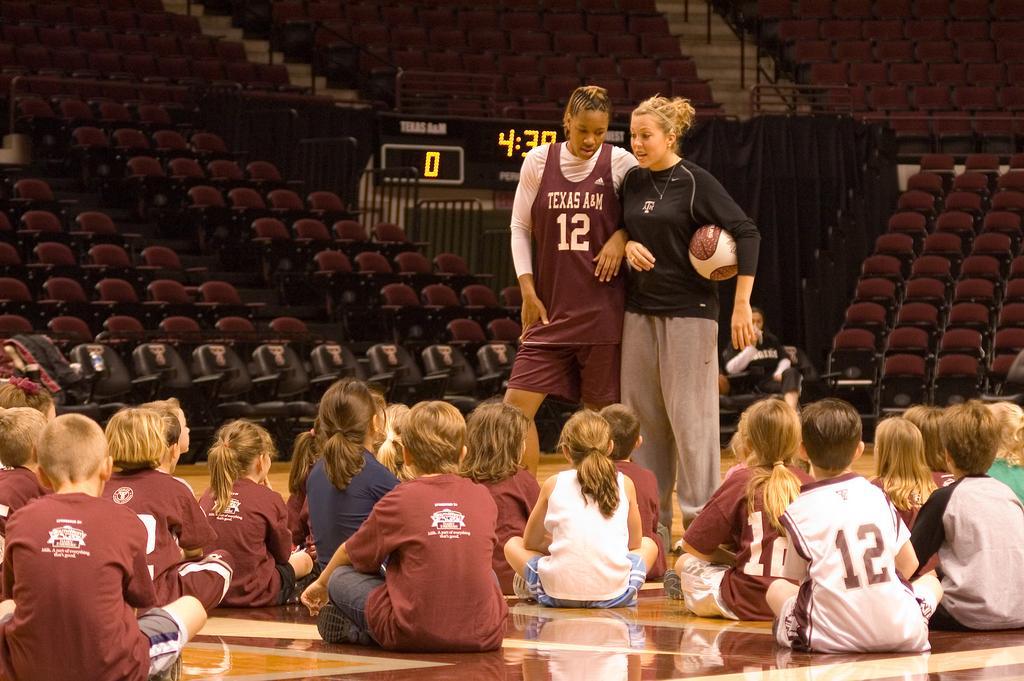In one or two sentences, can you explain what this image depicts? In this image I can see children sitting on the floor. There are 2 women standing and a person is holding a ball. There is a digital clock and chairs at the back. 